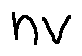Convert formula to latex. <formula><loc_0><loc_0><loc_500><loc_500>n v</formula> 